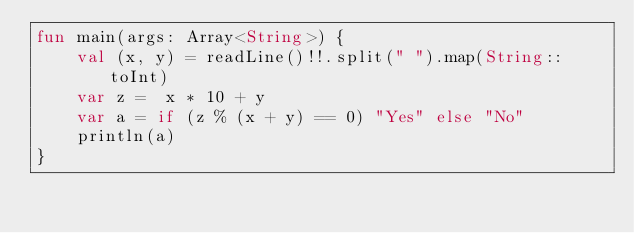Convert code to text. <code><loc_0><loc_0><loc_500><loc_500><_Kotlin_>fun main(args: Array<String>) {
    val (x, y) = readLine()!!.split(" ").map(String::toInt)
    var z =  x * 10 + y
    var a = if (z % (x + y) == 0) "Yes" else "No"
    println(a)
}</code> 